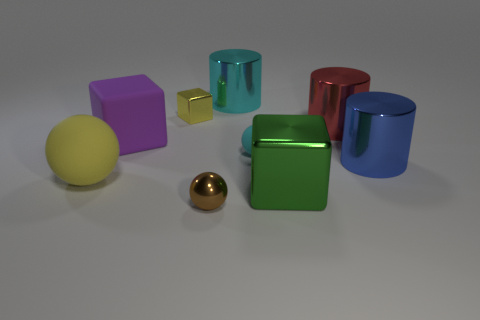Are there the same number of big matte things that are behind the blue shiny object and large rubber balls that are left of the yellow rubber thing?
Offer a terse response. No. Are there any other things that are made of the same material as the big cyan cylinder?
Ensure brevity in your answer.  Yes. Does the cyan metallic cylinder have the same size as the shiny cube on the left side of the big cyan shiny thing?
Make the answer very short. No. What is the thing that is in front of the green thing left of the big blue thing made of?
Make the answer very short. Metal. Are there the same number of small cyan matte things on the left side of the big cyan shiny cylinder and red shiny things?
Offer a very short reply. No. There is a thing that is on the left side of the brown thing and behind the red cylinder; how big is it?
Offer a very short reply. Small. What is the color of the big cube right of the tiny shiny object in front of the large red shiny thing?
Your response must be concise. Green. How many purple objects are big cubes or small metallic objects?
Make the answer very short. 1. What is the color of the sphere that is both to the left of the cyan metallic object and to the right of the purple rubber cube?
Make the answer very short. Brown. What number of large objects are purple metal blocks or red cylinders?
Make the answer very short. 1. 